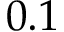<formula> <loc_0><loc_0><loc_500><loc_500>0 . 1</formula> 